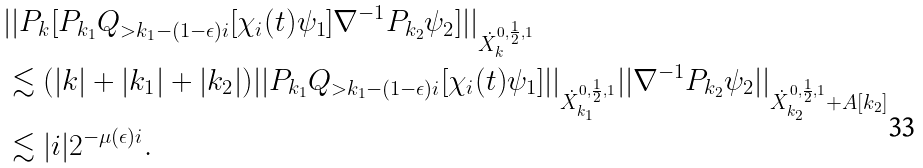Convert formula to latex. <formula><loc_0><loc_0><loc_500><loc_500>& | | P _ { k } [ P _ { k _ { 1 } } Q _ { > k _ { 1 } - ( 1 - \epsilon ) i } [ \chi _ { i } ( t ) \psi _ { 1 } ] \nabla ^ { - 1 } P _ { k _ { 2 } } \psi _ { 2 } ] | | _ { \dot { X } _ { k } ^ { 0 , \frac { 1 } { 2 } , 1 } } \\ & \lesssim ( | k | + | k _ { 1 } | + | k _ { 2 } | ) | | P _ { k _ { 1 } } Q _ { > k _ { 1 } - ( 1 - \epsilon ) i } [ \chi _ { i } ( t ) \psi _ { 1 } ] | | _ { \dot { X } _ { k _ { 1 } } ^ { 0 , \frac { 1 } { 2 } , 1 } } | | \nabla ^ { - 1 } P _ { k _ { 2 } } \psi _ { 2 } | | _ { \dot { X } _ { k _ { 2 } } ^ { 0 , \frac { 1 } { 2 } , 1 } + A [ k _ { 2 } ] } \\ & \lesssim | i | 2 ^ { - \mu ( \epsilon ) i } . \\</formula> 